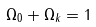Convert formula to latex. <formula><loc_0><loc_0><loc_500><loc_500>\Omega _ { 0 } + \Omega _ { k } = 1</formula> 